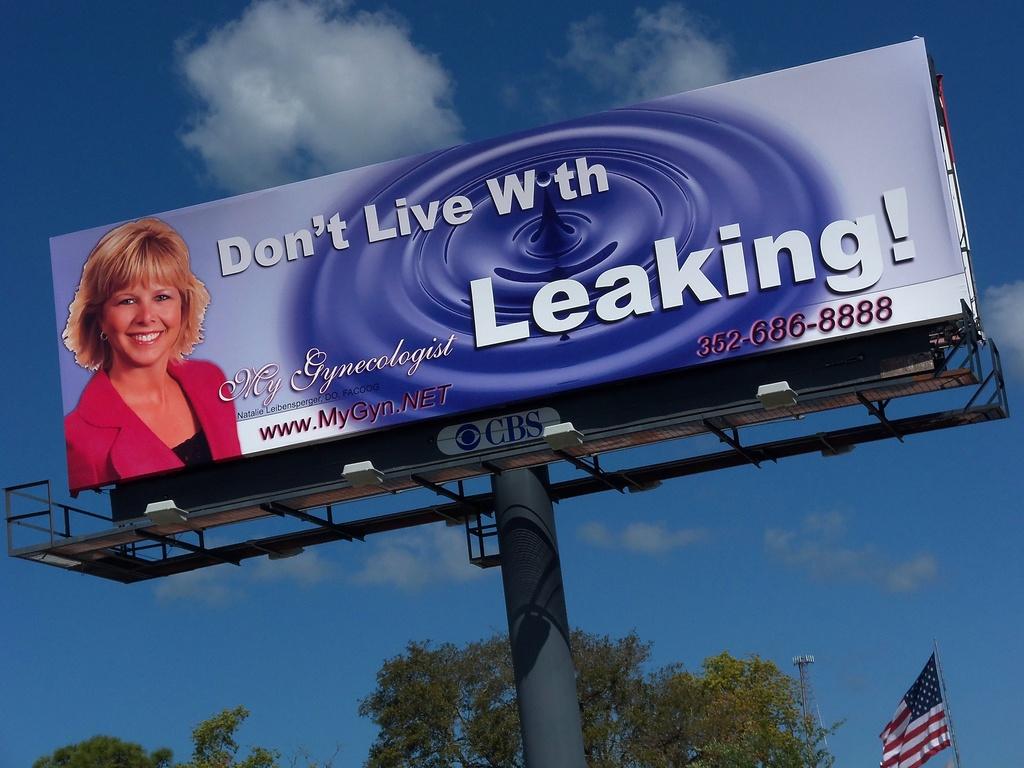What is the website?
Your response must be concise. Www.mygyn.net. 